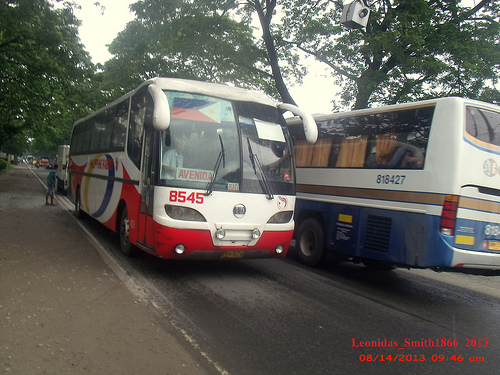<image>
Is the bus behind the bus? No. The bus is not behind the bus. From this viewpoint, the bus appears to be positioned elsewhere in the scene. 